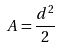Convert formula to latex. <formula><loc_0><loc_0><loc_500><loc_500>A = \frac { d ^ { 2 } } { 2 }</formula> 